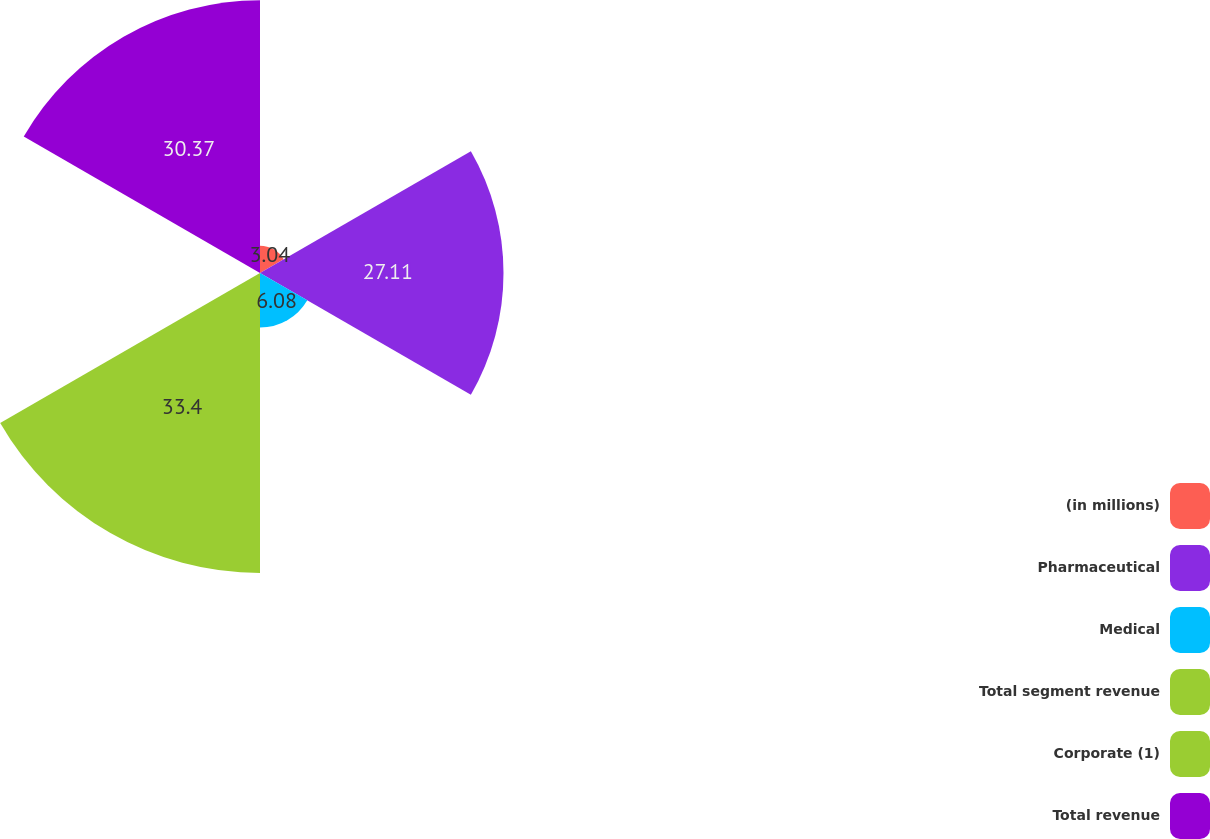Convert chart to OTSL. <chart><loc_0><loc_0><loc_500><loc_500><pie_chart><fcel>(in millions)<fcel>Pharmaceutical<fcel>Medical<fcel>Total segment revenue<fcel>Corporate (1)<fcel>Total revenue<nl><fcel>3.04%<fcel>27.11%<fcel>6.08%<fcel>33.4%<fcel>0.0%<fcel>30.37%<nl></chart> 